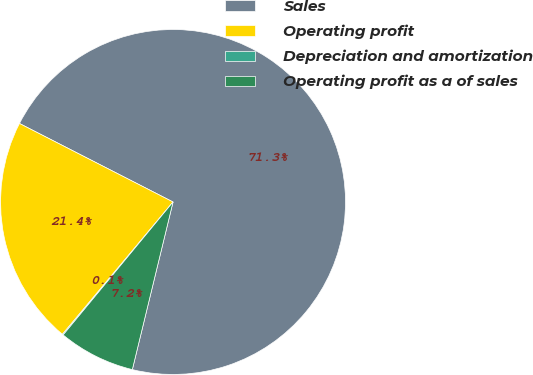Convert chart to OTSL. <chart><loc_0><loc_0><loc_500><loc_500><pie_chart><fcel>Sales<fcel>Operating profit<fcel>Depreciation and amortization<fcel>Operating profit as a of sales<nl><fcel>71.27%<fcel>21.44%<fcel>0.09%<fcel>7.2%<nl></chart> 